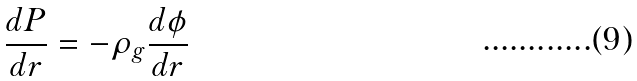Convert formula to latex. <formula><loc_0><loc_0><loc_500><loc_500>\frac { d P } { d r } = - \rho _ { g } \frac { d \phi } { d r }</formula> 